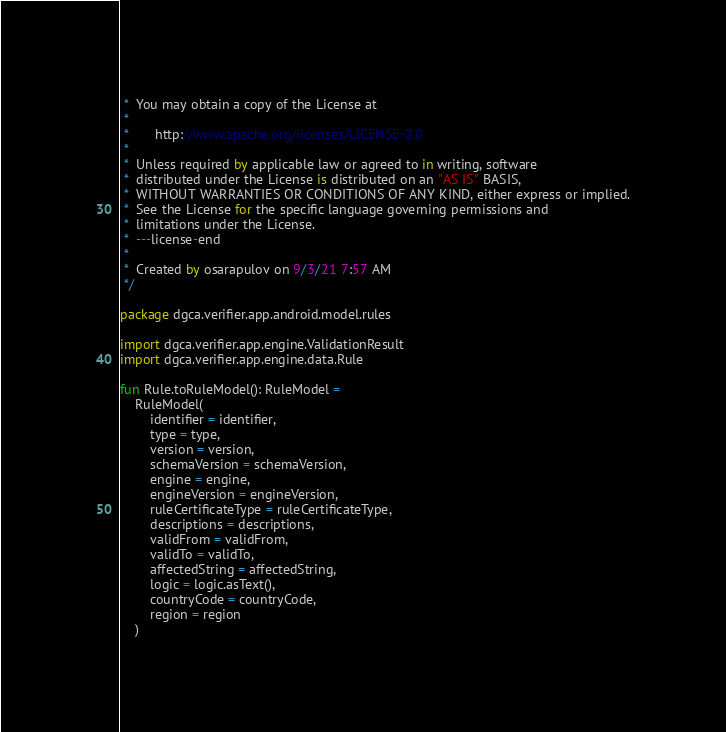<code> <loc_0><loc_0><loc_500><loc_500><_Kotlin_> *  You may obtain a copy of the License at
 *
 *       http://www.apache.org/licenses/LICENSE-2.0
 *
 *  Unless required by applicable law or agreed to in writing, software
 *  distributed under the License is distributed on an "AS IS" BASIS,
 *  WITHOUT WARRANTIES OR CONDITIONS OF ANY KIND, either express or implied.
 *  See the License for the specific language governing permissions and
 *  limitations under the License.
 *  ---license-end
 *
 *  Created by osarapulov on 9/3/21 7:57 AM
 */

package dgca.verifier.app.android.model.rules

import dgca.verifier.app.engine.ValidationResult
import dgca.verifier.app.engine.data.Rule

fun Rule.toRuleModel(): RuleModel =
    RuleModel(
        identifier = identifier,
        type = type,
        version = version,
        schemaVersion = schemaVersion,
        engine = engine,
        engineVersion = engineVersion,
        ruleCertificateType = ruleCertificateType,
        descriptions = descriptions,
        validFrom = validFrom,
        validTo = validTo,
        affectedString = affectedString,
        logic = logic.asText(),
        countryCode = countryCode,
        region = region
    )
</code> 